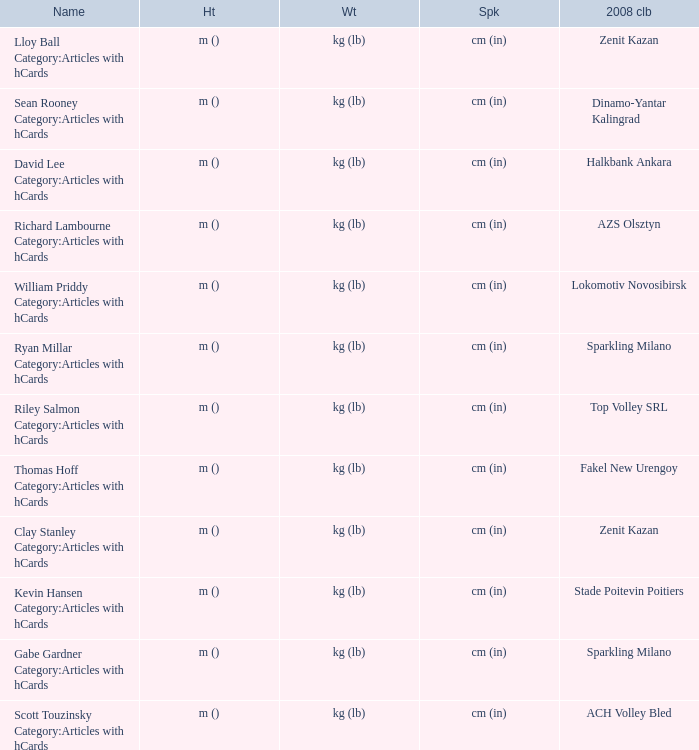What name has Fakel New Urengoy as the 2008 club? Thomas Hoff Category:Articles with hCards. 